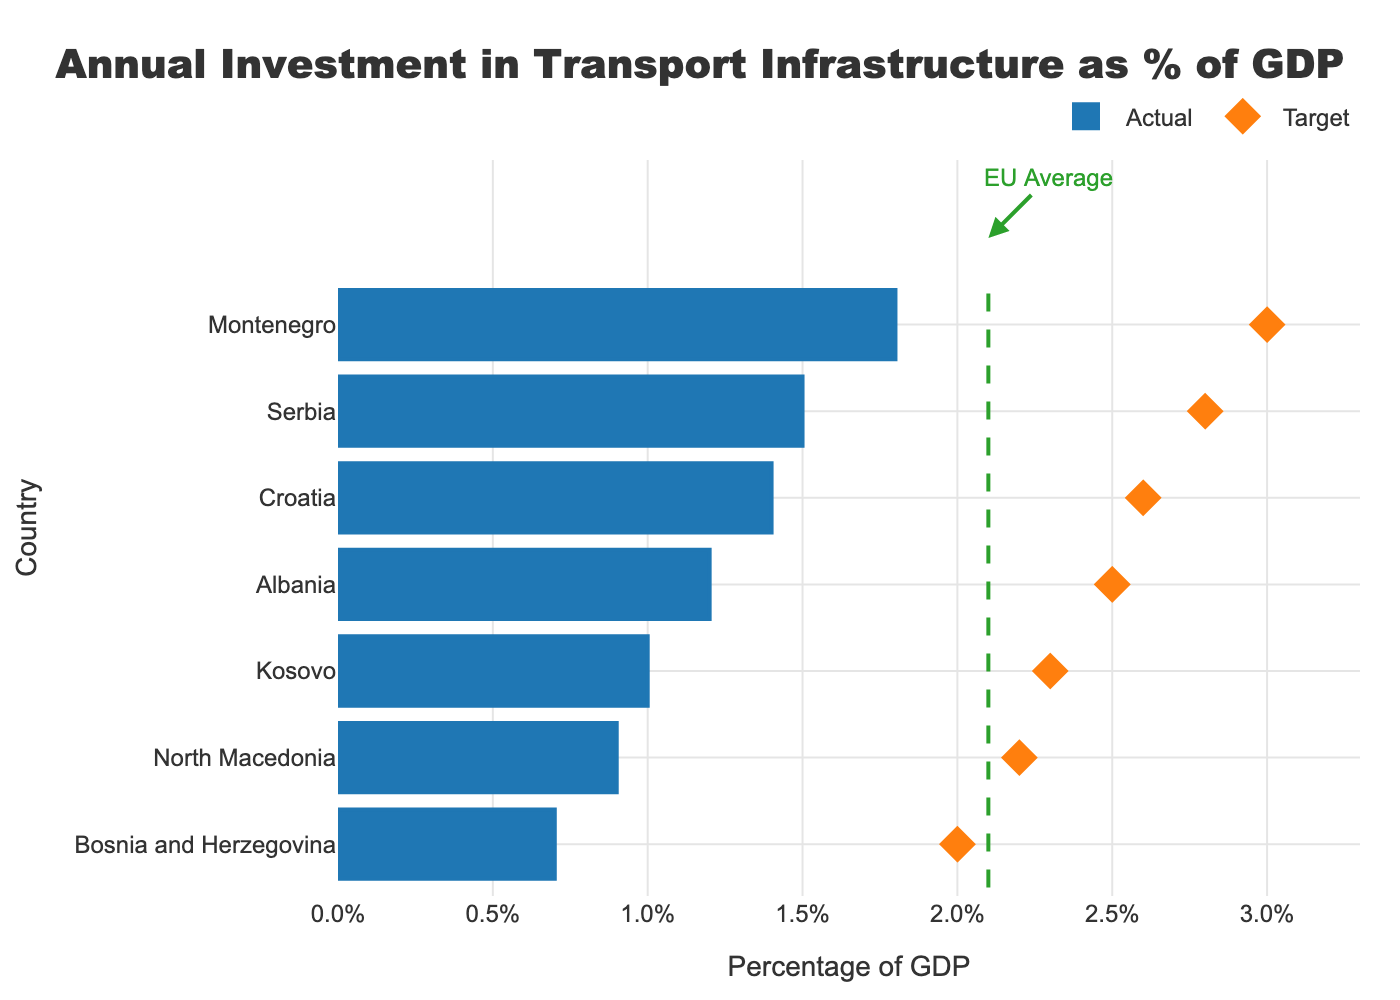What is the title of the plot? The title is usually located at the top of the plot. In this case, it mentions "Annual Investment in Transport Infrastructure as % of GDP"
Answer: Annual Investment in Transport Infrastructure as % of GDP Which country has the highest actual investment in transport infrastructure as a percentage of GDP? By examining the lengths of the blue bars, Montenegro has the longest bar in the graph
Answer: Montenegro Which country has the lowest actual investment in transport infrastructure as a percentage of GDP? By looking at the lengths of the blue bars, Bosnia and Herzegovina has the shortest bar
Answer: Bosnia and Herzegovina What is the EU average investment in transport infrastructure as a percentage of GDP? The green dashed line represents the EU average which is annotated on the graph
Answer: 2.1% Which country's actual investment is closest to the EU average? Albania's blue bar is closest to the green dashed line representing the EU average
Answer: Albania What is the target investment value for Croatia? The target investment value for each country is represented by the orange diamonds. Locate Croatia on the y-axis and find the corresponding orange diamond for its target value
Answer: 2.6% Which country has the largest gap between actual and target investment? Calculate the difference between the blue bar and orange diamond for each country. Montenegro has the largest difference between its actual (1.8%) and target (3.0%) investments
Answer: Montenegro How many Balkan countries have an actual investment in transport infrastructure below the EU average? Count the number of blue bars that are to the left of the green dashed line representing the EU average (2.1%). The countries are North Macedonia, Bosnia and Herzegovina, Kosovo, and Croatia
Answer: 4 Which country has an actual investment in transport infrastructure above both its target and the EU average? Scan the plot and find that Serbia’s blue bar crosses its own target and the green dashed line representing the EU average
Answer: Serbia What is the range of actual investment values in the dataset? The range is the difference between the highest and the lowest actual values. Montenegro has the highest (1.8%) and Bosnia and Herzegovina has the lowest (0.7%). So, the range is 1.8% - 0.7%
Answer: 1.1% 